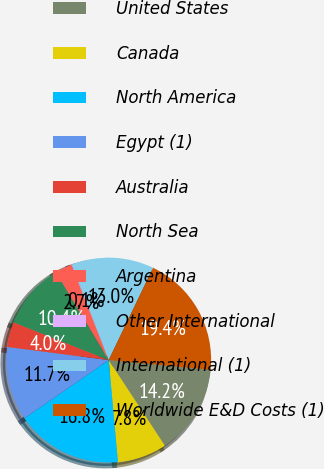<chart> <loc_0><loc_0><loc_500><loc_500><pie_chart><fcel>United States<fcel>Canada<fcel>North America<fcel>Egypt (1)<fcel>Australia<fcel>North Sea<fcel>Argentina<fcel>Other International<fcel>International (1)<fcel>Worldwide E&D Costs (1)<nl><fcel>14.24%<fcel>7.81%<fcel>16.82%<fcel>11.67%<fcel>3.96%<fcel>10.39%<fcel>2.67%<fcel>0.1%<fcel>12.96%<fcel>19.39%<nl></chart> 